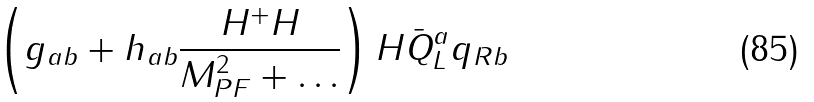<formula> <loc_0><loc_0><loc_500><loc_500>\left ( g _ { a b } + h _ { a b } { \frac { H ^ { + } H } { M _ { P F } ^ { 2 } + \dots } } \right ) H \bar { Q } _ { L } ^ { a } q _ { R b }</formula> 